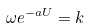<formula> <loc_0><loc_0><loc_500><loc_500>\omega e ^ { - a U } = k</formula> 